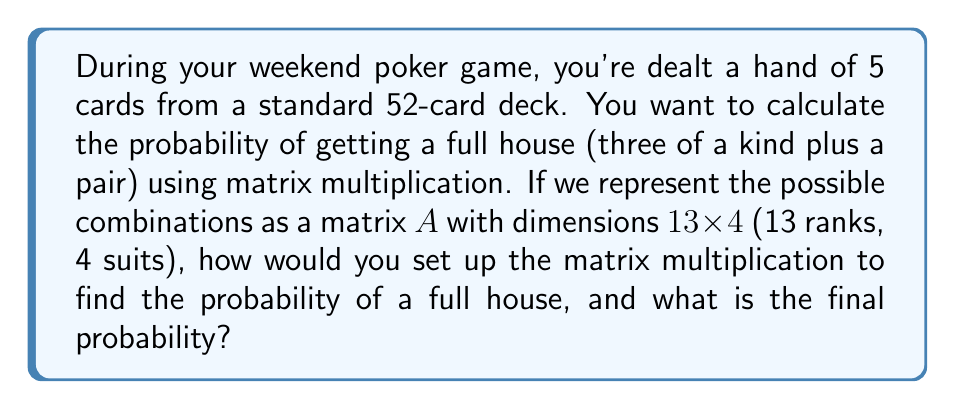Show me your answer to this math problem. Let's approach this step-by-step:

1) First, we need to understand what a full house consists of:
   - Three cards of one rank
   - Two cards of another rank

2) We can represent this as a matrix multiplication problem:

   $$ P(\text{Full House}) = \frac{(\text{ways to choose 3 of a kind}) \times (\text{ways to choose a pair})}{(\text{total number of 5-card hands})} $$

3) Let's set up matrix $A$ (13 x 4) to represent all possible card combinations:
   
   $$ A = \begin{bmatrix}
   1 & 1 & 1 & 1 \\
   1 & 1 & 1 & 1 \\
   \vdots & \vdots & \vdots & \vdots \\
   1 & 1 & 1 & 1
   \end{bmatrix} $$

4) To choose 3 of a kind, we need to select 1 rank (13 ways) and then 3 out of 4 suits for that rank:

   $$ \text{Ways to choose 3 of a kind} = 13 \times \binom{4}{3} = 13 \times 4 = 52 $$

5) For the pair, we need to select 1 rank from the remaining 12 and then 2 out of 4 suits:

   $$ \text{Ways to choose a pair} = 12 \times \binom{4}{2} = 12 \times 6 = 72 $$

6) The total number of ways to get a full house is:

   $$ 52 \times 72 = 3,744 $$

7) The total number of 5-card hands is:

   $$ \binom{52}{5} = 2,598,960 $$

8) Therefore, the probability of getting a full house is:

   $$ P(\text{Full House}) = \frac{3,744}{2,598,960} = \frac{6}{4165} \approx 0.00144 $$

This can be represented as a matrix multiplication:

$$ \left[ \begin{array}{cccc}
1 & 1 & 1 & 1 \\
\vdots & \vdots & \vdots & \vdots \\
1 & 1 & 1 & 1
\end{array} \right]_{13 \times 4}
\times
\left[ \begin{array}{c}
\binom{4}{3} \\
0 \\
0 \\
0
\end{array} \right]_{4 \times 1}
\times
\left[ \begin{array}{cccc}
1 & 1 & 1 & 1 \\
\vdots & \vdots & \vdots & \vdots \\
1 & 1 & 1 & 1
\end{array} \right]_{12 \times 4}
\times
\left[ \begin{array}{c}
\binom{4}{2} \\
0 \\
0 \\
0
\end{array} \right]_{4 \times 1}
\div \binom{52}{5} $$

This matrix multiplication gives us the same result as our calculation above.
Answer: $\frac{6}{4165} \approx 0.00144$ 